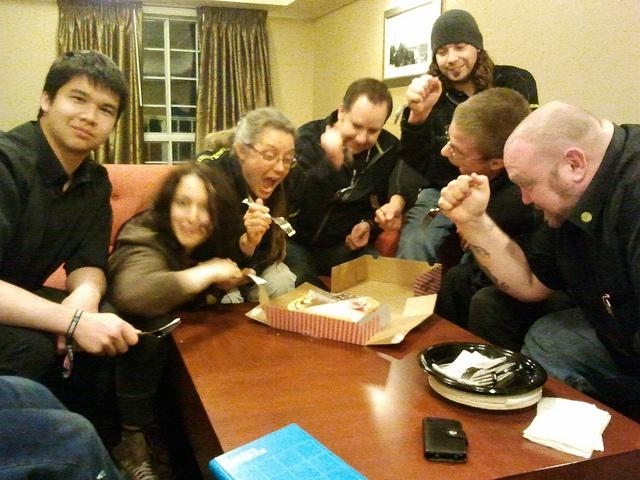Describe the objects in this image and their specific colors. I can see dining table in tan, brown, black, orange, and ivory tones, people in tan, black, and olive tones, people in tan and black tones, people in tan, black, and olive tones, and people in tan, black, olive, and maroon tones in this image. 